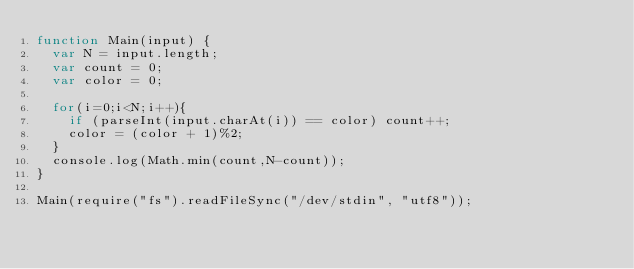Convert code to text. <code><loc_0><loc_0><loc_500><loc_500><_JavaScript_>function Main(input) {
  var N = input.length;
  var count = 0;
  var color = 0;
  
  for(i=0;i<N;i++){
    if (parseInt(input.charAt(i)) == color) count++;
    color = (color + 1)%2;
  }
  console.log(Math.min(count,N-count));
}
 
Main(require("fs").readFileSync("/dev/stdin", "utf8"));</code> 